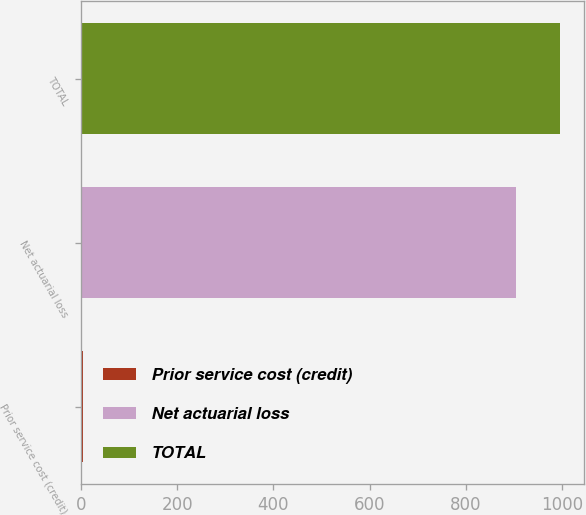<chart> <loc_0><loc_0><loc_500><loc_500><bar_chart><fcel>Prior service cost (credit)<fcel>Net actuarial loss<fcel>TOTAL<nl><fcel>4<fcel>904.7<fcel>995.17<nl></chart> 